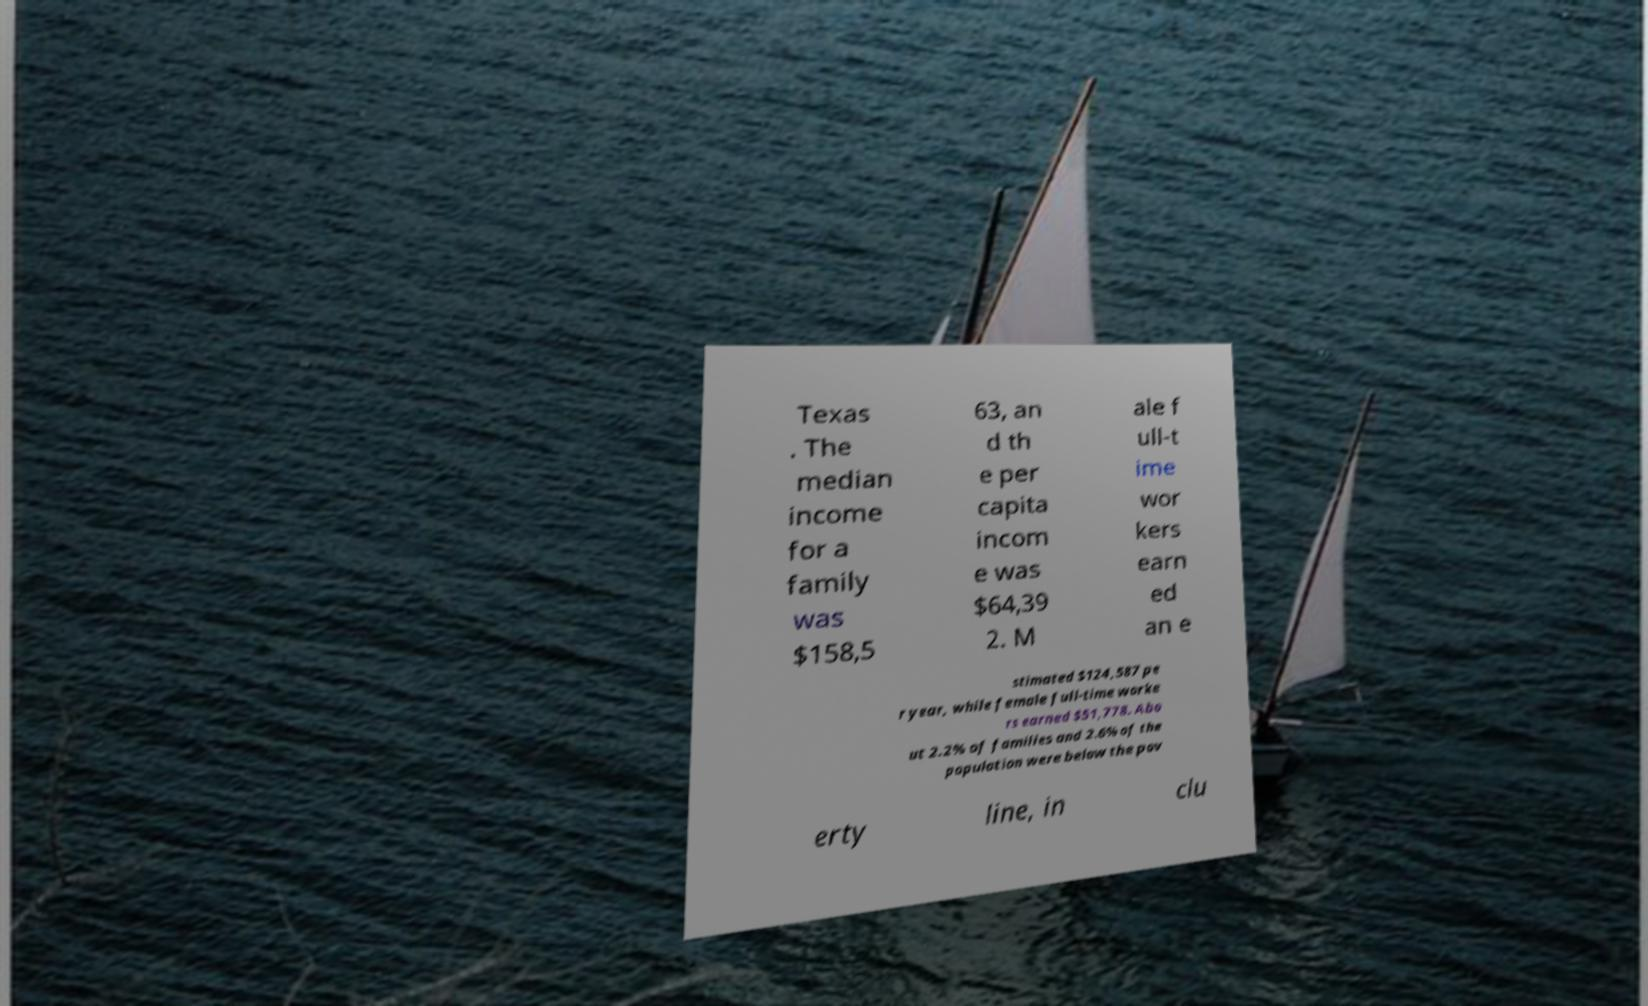Can you accurately transcribe the text from the provided image for me? Texas . The median income for a family was $158,5 63, an d th e per capita incom e was $64,39 2. M ale f ull-t ime wor kers earn ed an e stimated $124,587 pe r year, while female full-time worke rs earned $51,778. Abo ut 2.2% of families and 2.6% of the population were below the pov erty line, in clu 